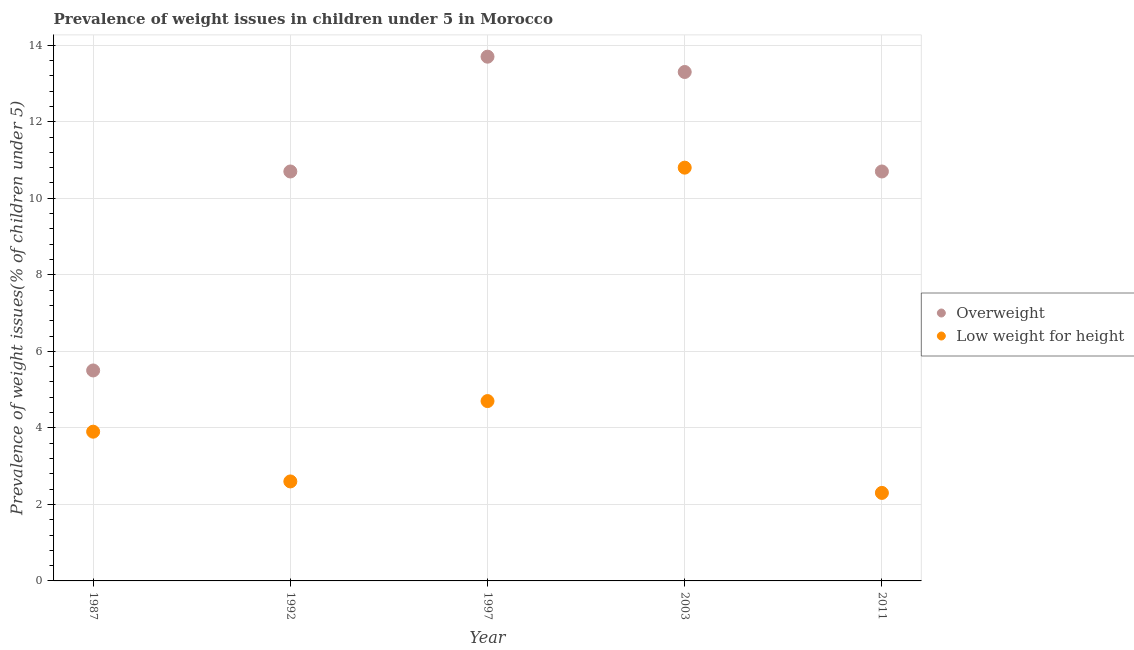How many different coloured dotlines are there?
Your answer should be very brief. 2. Is the number of dotlines equal to the number of legend labels?
Offer a terse response. Yes. What is the percentage of underweight children in 2011?
Keep it short and to the point. 2.3. Across all years, what is the maximum percentage of underweight children?
Provide a short and direct response. 10.8. In which year was the percentage of overweight children maximum?
Offer a very short reply. 1997. What is the total percentage of underweight children in the graph?
Keep it short and to the point. 24.3. What is the difference between the percentage of underweight children in 1987 and that in 2011?
Offer a terse response. 1.6. What is the difference between the percentage of underweight children in 2003 and the percentage of overweight children in 1992?
Provide a short and direct response. 0.1. What is the average percentage of overweight children per year?
Provide a short and direct response. 10.78. In the year 1987, what is the difference between the percentage of overweight children and percentage of underweight children?
Ensure brevity in your answer.  1.6. In how many years, is the percentage of overweight children greater than 5.2 %?
Offer a terse response. 5. What is the ratio of the percentage of overweight children in 2003 to that in 2011?
Ensure brevity in your answer.  1.24. Is the percentage of overweight children in 1997 less than that in 2011?
Ensure brevity in your answer.  No. What is the difference between the highest and the second highest percentage of underweight children?
Provide a short and direct response. 6.1. What is the difference between the highest and the lowest percentage of underweight children?
Your response must be concise. 8.5. In how many years, is the percentage of underweight children greater than the average percentage of underweight children taken over all years?
Provide a short and direct response. 1. Does the percentage of underweight children monotonically increase over the years?
Ensure brevity in your answer.  No. Is the percentage of overweight children strictly greater than the percentage of underweight children over the years?
Give a very brief answer. Yes. Is the percentage of overweight children strictly less than the percentage of underweight children over the years?
Offer a terse response. No. What is the difference between two consecutive major ticks on the Y-axis?
Provide a short and direct response. 2. Are the values on the major ticks of Y-axis written in scientific E-notation?
Keep it short and to the point. No. Where does the legend appear in the graph?
Provide a short and direct response. Center right. How many legend labels are there?
Your answer should be compact. 2. What is the title of the graph?
Your answer should be very brief. Prevalence of weight issues in children under 5 in Morocco. What is the label or title of the X-axis?
Offer a very short reply. Year. What is the label or title of the Y-axis?
Offer a very short reply. Prevalence of weight issues(% of children under 5). What is the Prevalence of weight issues(% of children under 5) in Low weight for height in 1987?
Provide a succinct answer. 3.9. What is the Prevalence of weight issues(% of children under 5) in Overweight in 1992?
Offer a terse response. 10.7. What is the Prevalence of weight issues(% of children under 5) of Low weight for height in 1992?
Provide a succinct answer. 2.6. What is the Prevalence of weight issues(% of children under 5) of Overweight in 1997?
Keep it short and to the point. 13.7. What is the Prevalence of weight issues(% of children under 5) in Low weight for height in 1997?
Your response must be concise. 4.7. What is the Prevalence of weight issues(% of children under 5) in Overweight in 2003?
Offer a very short reply. 13.3. What is the Prevalence of weight issues(% of children under 5) in Low weight for height in 2003?
Offer a very short reply. 10.8. What is the Prevalence of weight issues(% of children under 5) of Overweight in 2011?
Provide a short and direct response. 10.7. What is the Prevalence of weight issues(% of children under 5) in Low weight for height in 2011?
Give a very brief answer. 2.3. Across all years, what is the maximum Prevalence of weight issues(% of children under 5) of Overweight?
Offer a very short reply. 13.7. Across all years, what is the maximum Prevalence of weight issues(% of children under 5) of Low weight for height?
Keep it short and to the point. 10.8. Across all years, what is the minimum Prevalence of weight issues(% of children under 5) of Low weight for height?
Offer a terse response. 2.3. What is the total Prevalence of weight issues(% of children under 5) of Overweight in the graph?
Keep it short and to the point. 53.9. What is the total Prevalence of weight issues(% of children under 5) of Low weight for height in the graph?
Your response must be concise. 24.3. What is the difference between the Prevalence of weight issues(% of children under 5) of Low weight for height in 1987 and that in 1992?
Offer a terse response. 1.3. What is the difference between the Prevalence of weight issues(% of children under 5) in Low weight for height in 1987 and that in 1997?
Make the answer very short. -0.8. What is the difference between the Prevalence of weight issues(% of children under 5) of Overweight in 1987 and that in 2003?
Your answer should be very brief. -7.8. What is the difference between the Prevalence of weight issues(% of children under 5) of Overweight in 1987 and that in 2011?
Ensure brevity in your answer.  -5.2. What is the difference between the Prevalence of weight issues(% of children under 5) in Overweight in 1992 and that in 2011?
Your answer should be compact. 0. What is the difference between the Prevalence of weight issues(% of children under 5) of Overweight in 1997 and that in 2011?
Offer a very short reply. 3. What is the difference between the Prevalence of weight issues(% of children under 5) in Low weight for height in 1997 and that in 2011?
Your answer should be compact. 2.4. What is the difference between the Prevalence of weight issues(% of children under 5) of Overweight in 2003 and that in 2011?
Offer a terse response. 2.6. What is the difference between the Prevalence of weight issues(% of children under 5) of Overweight in 1987 and the Prevalence of weight issues(% of children under 5) of Low weight for height in 1992?
Provide a short and direct response. 2.9. What is the difference between the Prevalence of weight issues(% of children under 5) of Overweight in 1997 and the Prevalence of weight issues(% of children under 5) of Low weight for height in 2011?
Offer a terse response. 11.4. What is the average Prevalence of weight issues(% of children under 5) in Overweight per year?
Make the answer very short. 10.78. What is the average Prevalence of weight issues(% of children under 5) in Low weight for height per year?
Offer a terse response. 4.86. In the year 2011, what is the difference between the Prevalence of weight issues(% of children under 5) in Overweight and Prevalence of weight issues(% of children under 5) in Low weight for height?
Ensure brevity in your answer.  8.4. What is the ratio of the Prevalence of weight issues(% of children under 5) of Overweight in 1987 to that in 1992?
Ensure brevity in your answer.  0.51. What is the ratio of the Prevalence of weight issues(% of children under 5) in Low weight for height in 1987 to that in 1992?
Provide a succinct answer. 1.5. What is the ratio of the Prevalence of weight issues(% of children under 5) of Overweight in 1987 to that in 1997?
Your answer should be very brief. 0.4. What is the ratio of the Prevalence of weight issues(% of children under 5) in Low weight for height in 1987 to that in 1997?
Your answer should be compact. 0.83. What is the ratio of the Prevalence of weight issues(% of children under 5) in Overweight in 1987 to that in 2003?
Your answer should be very brief. 0.41. What is the ratio of the Prevalence of weight issues(% of children under 5) of Low weight for height in 1987 to that in 2003?
Keep it short and to the point. 0.36. What is the ratio of the Prevalence of weight issues(% of children under 5) in Overweight in 1987 to that in 2011?
Provide a short and direct response. 0.51. What is the ratio of the Prevalence of weight issues(% of children under 5) of Low weight for height in 1987 to that in 2011?
Provide a succinct answer. 1.7. What is the ratio of the Prevalence of weight issues(% of children under 5) of Overweight in 1992 to that in 1997?
Provide a succinct answer. 0.78. What is the ratio of the Prevalence of weight issues(% of children under 5) of Low weight for height in 1992 to that in 1997?
Give a very brief answer. 0.55. What is the ratio of the Prevalence of weight issues(% of children under 5) in Overweight in 1992 to that in 2003?
Give a very brief answer. 0.8. What is the ratio of the Prevalence of weight issues(% of children under 5) in Low weight for height in 1992 to that in 2003?
Offer a terse response. 0.24. What is the ratio of the Prevalence of weight issues(% of children under 5) of Overweight in 1992 to that in 2011?
Your answer should be compact. 1. What is the ratio of the Prevalence of weight issues(% of children under 5) in Low weight for height in 1992 to that in 2011?
Offer a very short reply. 1.13. What is the ratio of the Prevalence of weight issues(% of children under 5) in Overweight in 1997 to that in 2003?
Provide a succinct answer. 1.03. What is the ratio of the Prevalence of weight issues(% of children under 5) in Low weight for height in 1997 to that in 2003?
Your answer should be compact. 0.44. What is the ratio of the Prevalence of weight issues(% of children under 5) in Overweight in 1997 to that in 2011?
Your response must be concise. 1.28. What is the ratio of the Prevalence of weight issues(% of children under 5) of Low weight for height in 1997 to that in 2011?
Provide a succinct answer. 2.04. What is the ratio of the Prevalence of weight issues(% of children under 5) in Overweight in 2003 to that in 2011?
Give a very brief answer. 1.24. What is the ratio of the Prevalence of weight issues(% of children under 5) of Low weight for height in 2003 to that in 2011?
Provide a short and direct response. 4.7. What is the difference between the highest and the second highest Prevalence of weight issues(% of children under 5) of Overweight?
Offer a terse response. 0.4. What is the difference between the highest and the lowest Prevalence of weight issues(% of children under 5) in Overweight?
Your answer should be compact. 8.2. What is the difference between the highest and the lowest Prevalence of weight issues(% of children under 5) in Low weight for height?
Offer a very short reply. 8.5. 